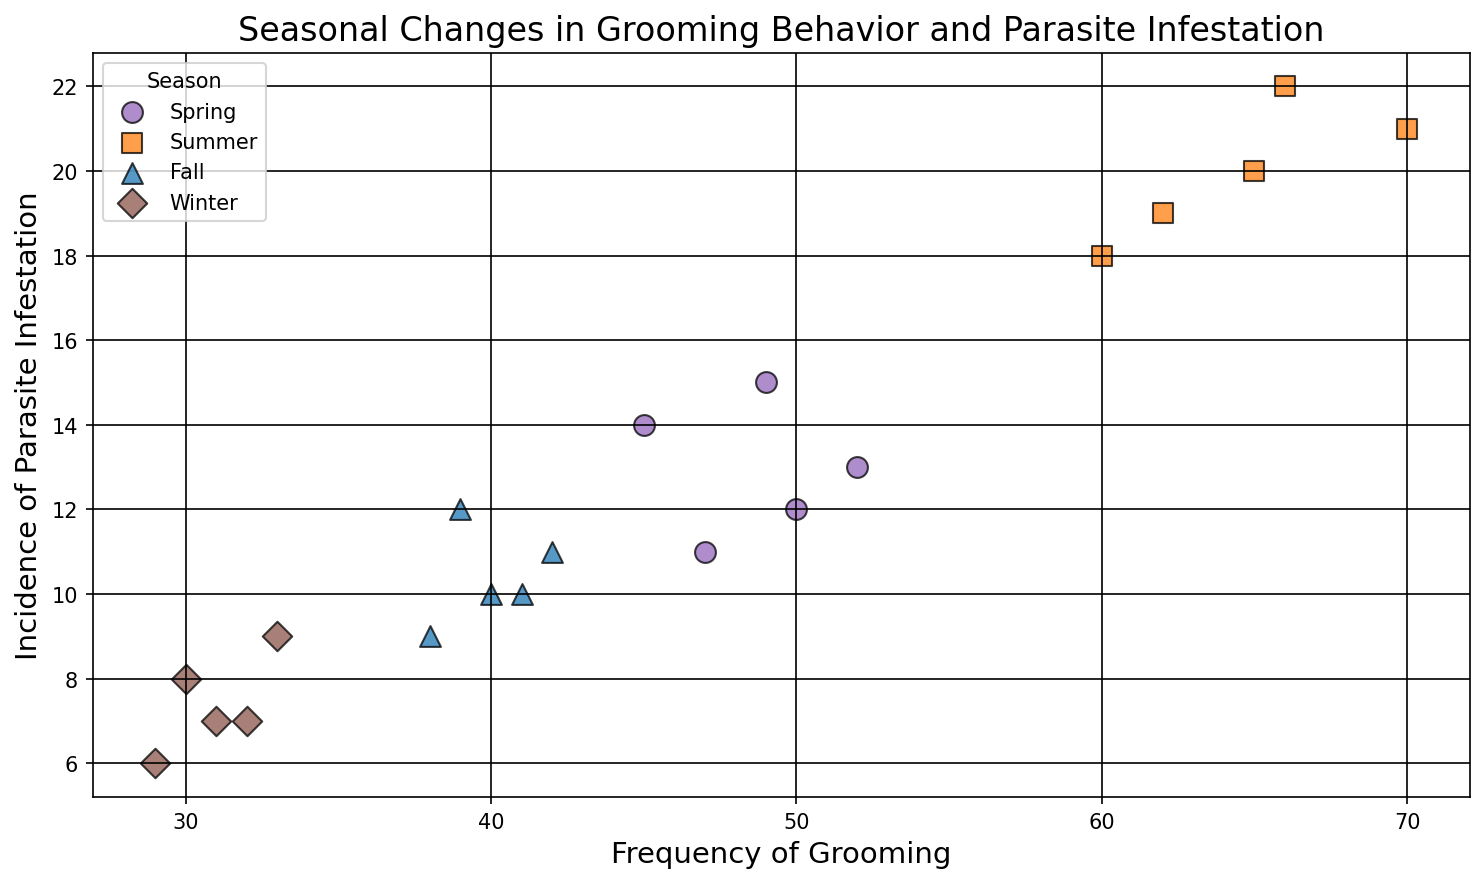What color and shape represent the Winter season in the scatter plot? The legend in the scatter plot indicates that the Winter season is represented by brown diamonds.
Answer: Brown diamonds Which season has the data points with the highest incidence of parasite infestation? By examining the y-axis values, the data points with the highest incidence of parasite infestation are in the Summer season.
Answer: Summer What is the average frequency of grooming in the Fall season? The frequencies of grooming in the Fall season are 40, 42, 38, 39, and 41. Summing these values: 40 + 42 + 38 + 39 + 41 = 200. Dividing by the number of data points, 200/5 = 40.
Answer: 40 In which season is the incidence of parasite infestation more varied, measured by the range (difference between highest and lowest values)? For each season, calculate the range:
- Spring: max(15) - min(11) = 4
- Summer: max(22) - min(18) = 4
- Fall: max(12) - min(9) = 3
- Winter: max(9) - min(6) = 3
Both Spring and Summer have a range of 4, making them the most varied.
Answer: Spring and Summer Is there a noticeable trend in grooming frequency between Winter and Summer, based on the figure? By observing the x-axis, the grooming frequency increases significantly from Winter (around 30-33) to Summer (around 60-70).
Answer: Yes, it increases 